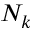<formula> <loc_0><loc_0><loc_500><loc_500>N _ { k }</formula> 